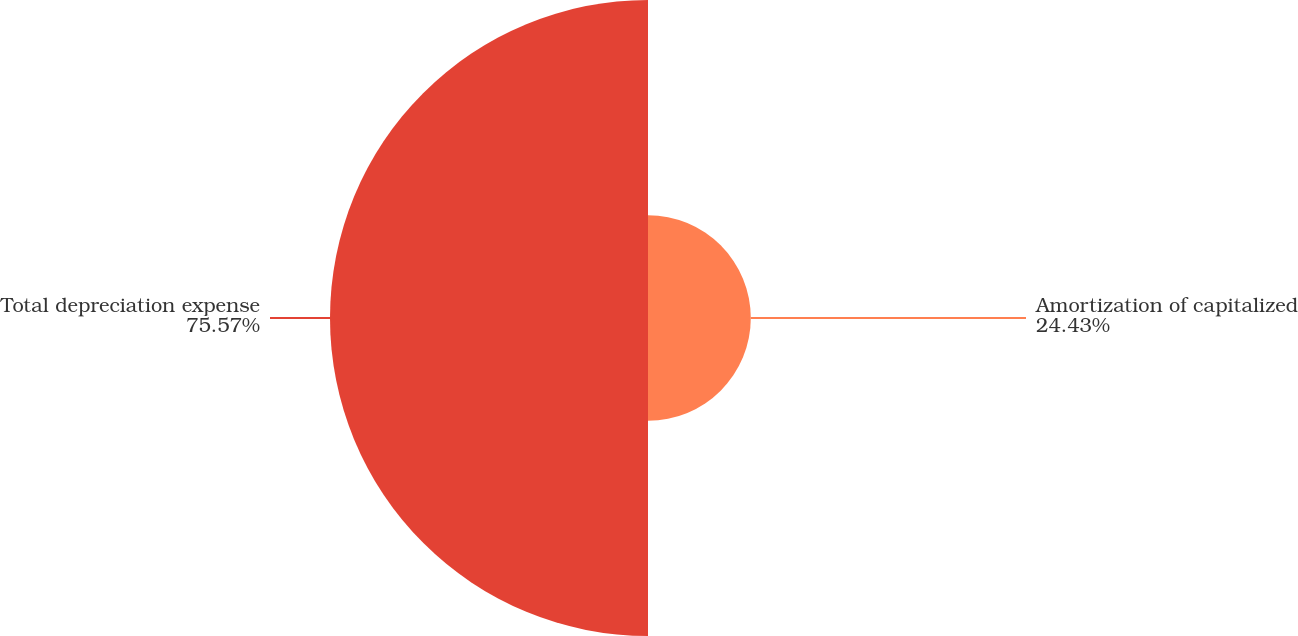Convert chart. <chart><loc_0><loc_0><loc_500><loc_500><pie_chart><fcel>Amortization of capitalized<fcel>Total depreciation expense<nl><fcel>24.43%<fcel>75.57%<nl></chart> 